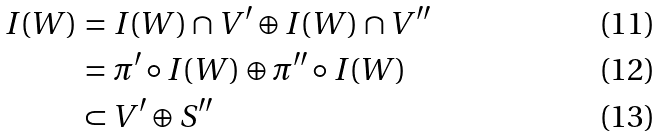<formula> <loc_0><loc_0><loc_500><loc_500>I ( W ) & = I ( W ) \cap V ^ { \prime } \oplus I ( W ) \cap V ^ { \prime \prime } \\ & = \pi ^ { \prime } \circ I ( W ) \oplus \pi ^ { \prime \prime } \circ I ( W ) \\ & \subset V ^ { \prime } \oplus S ^ { \prime \prime }</formula> 